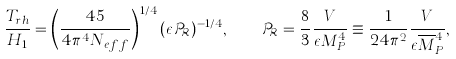<formula> <loc_0><loc_0><loc_500><loc_500>\frac { T _ { r h } } { H _ { 1 } } = \left ( \frac { 4 5 } { 4 \pi ^ { 4 } N _ { e f f } } \right ) ^ { 1 / 4 } ( \epsilon \, { \mathcal { P } } _ { \mathcal { R } } ) ^ { - 1 / 4 } , \quad { \mathcal { P } } _ { \mathcal { R } } = \frac { 8 } { 3 } \frac { V } { \epsilon M _ { P } ^ { 4 } } \equiv \frac { 1 } { 2 4 \pi ^ { 2 } } \frac { V } { \epsilon \overline { M } _ { P } ^ { 4 } } ,</formula> 